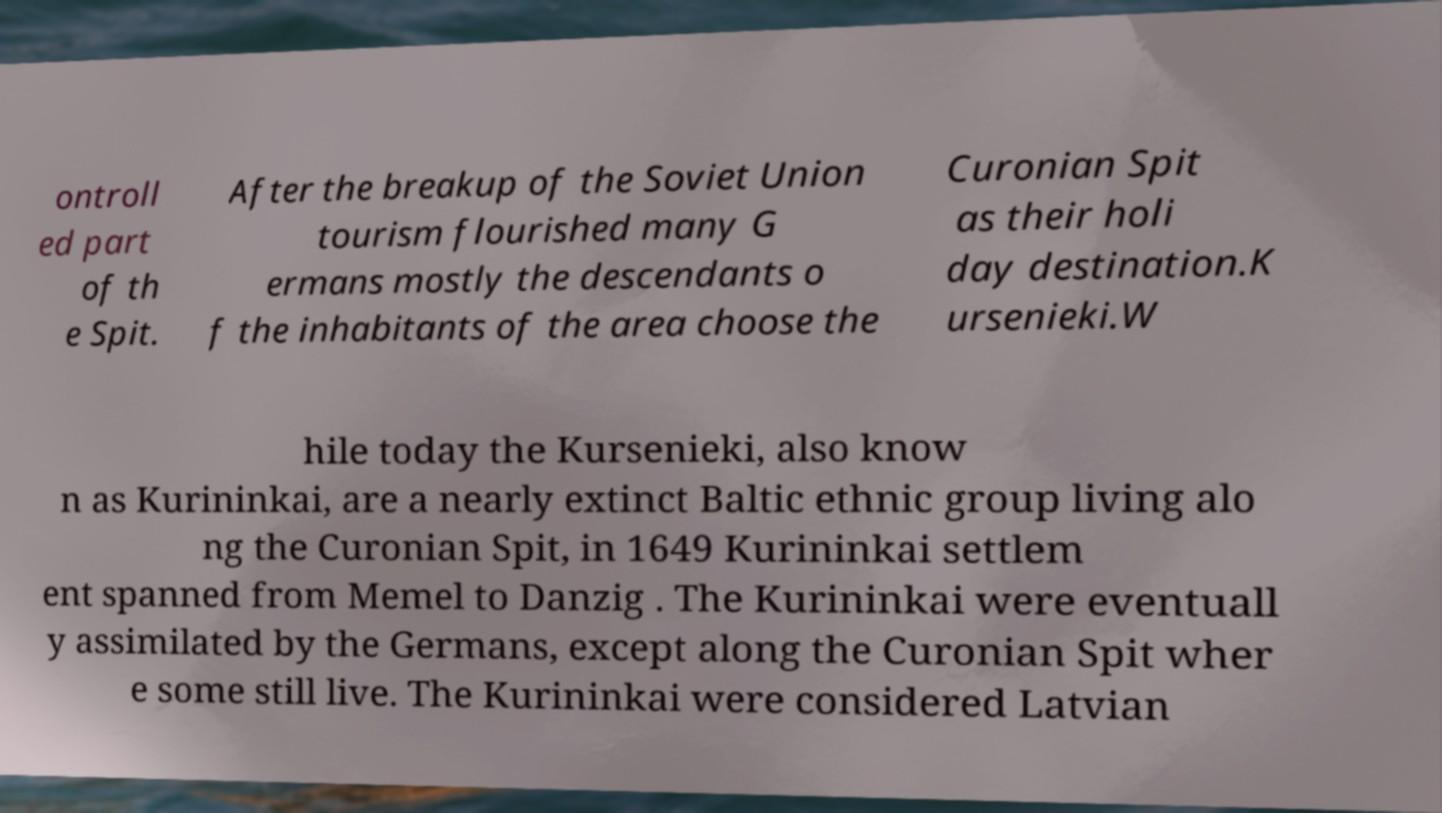I need the written content from this picture converted into text. Can you do that? ontroll ed part of th e Spit. After the breakup of the Soviet Union tourism flourished many G ermans mostly the descendants o f the inhabitants of the area choose the Curonian Spit as their holi day destination.K ursenieki.W hile today the Kursenieki, also know n as Kurininkai, are a nearly extinct Baltic ethnic group living alo ng the Curonian Spit, in 1649 Kurininkai settlem ent spanned from Memel to Danzig . The Kurininkai were eventuall y assimilated by the Germans, except along the Curonian Spit wher e some still live. The Kurininkai were considered Latvian 